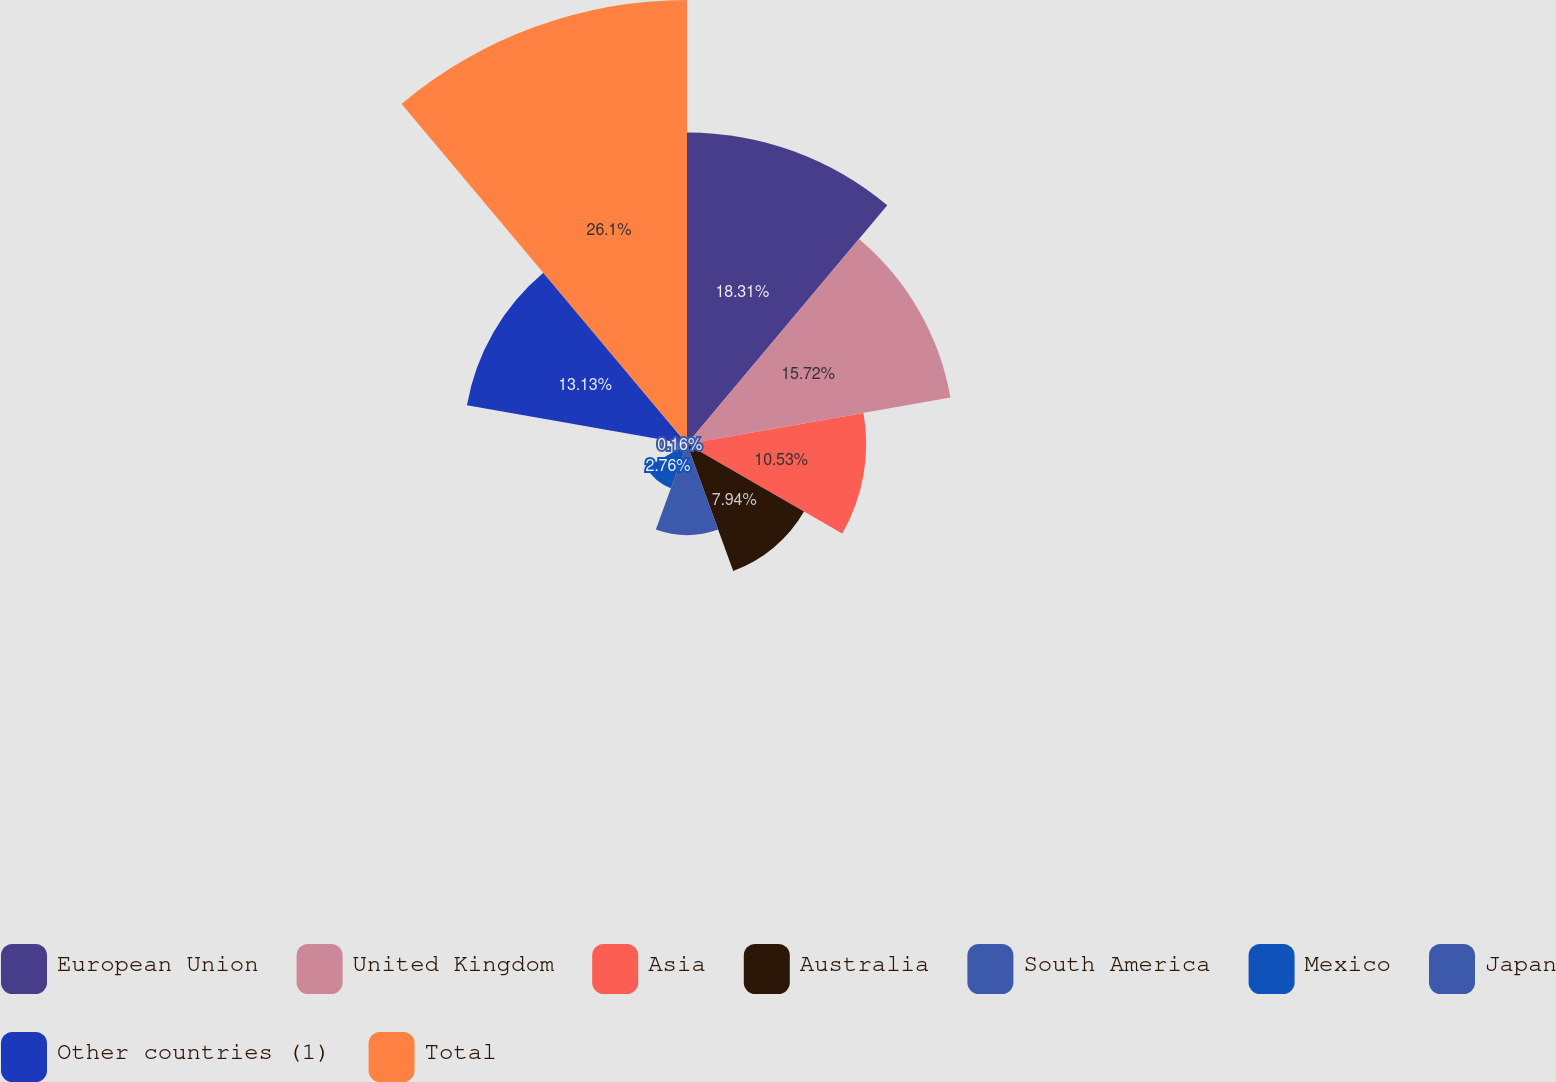<chart> <loc_0><loc_0><loc_500><loc_500><pie_chart><fcel>European Union<fcel>United Kingdom<fcel>Asia<fcel>Australia<fcel>South America<fcel>Mexico<fcel>Japan<fcel>Other countries (1)<fcel>Total<nl><fcel>18.31%<fcel>15.72%<fcel>10.53%<fcel>7.94%<fcel>5.35%<fcel>2.76%<fcel>0.16%<fcel>13.13%<fcel>26.09%<nl></chart> 